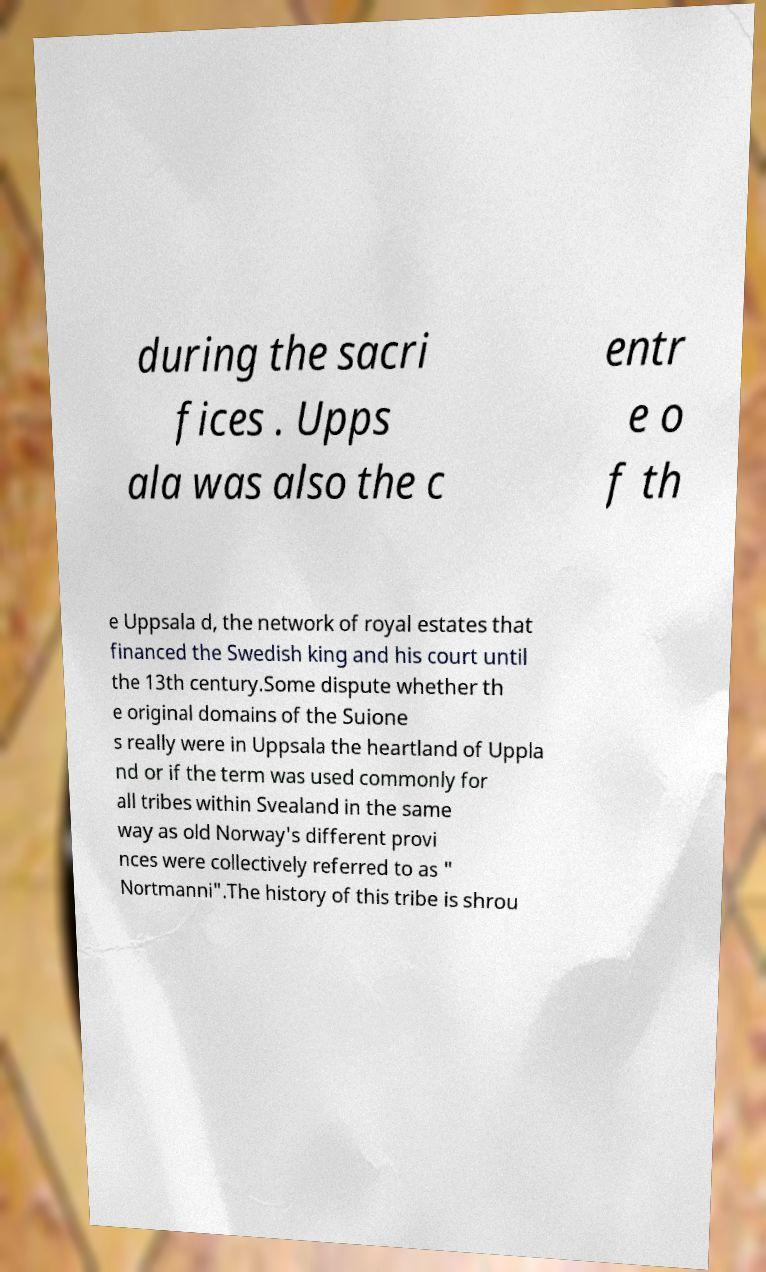Could you assist in decoding the text presented in this image and type it out clearly? during the sacri fices . Upps ala was also the c entr e o f th e Uppsala d, the network of royal estates that financed the Swedish king and his court until the 13th century.Some dispute whether th e original domains of the Suione s really were in Uppsala the heartland of Uppla nd or if the term was used commonly for all tribes within Svealand in the same way as old Norway's different provi nces were collectively referred to as " Nortmanni".The history of this tribe is shrou 